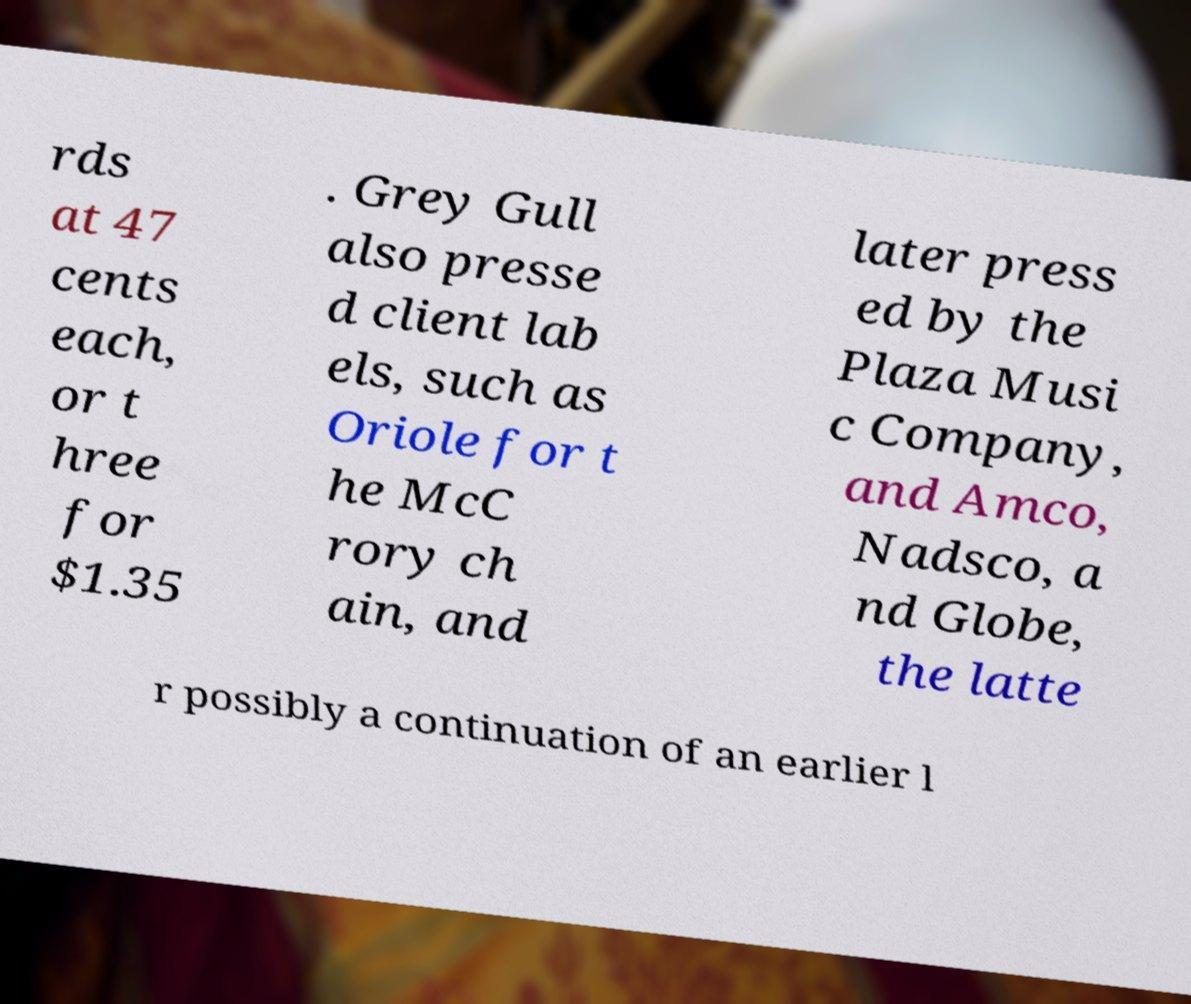What messages or text are displayed in this image? I need them in a readable, typed format. rds at 47 cents each, or t hree for $1.35 . Grey Gull also presse d client lab els, such as Oriole for t he McC rory ch ain, and later press ed by the Plaza Musi c Company, and Amco, Nadsco, a nd Globe, the latte r possibly a continuation of an earlier l 